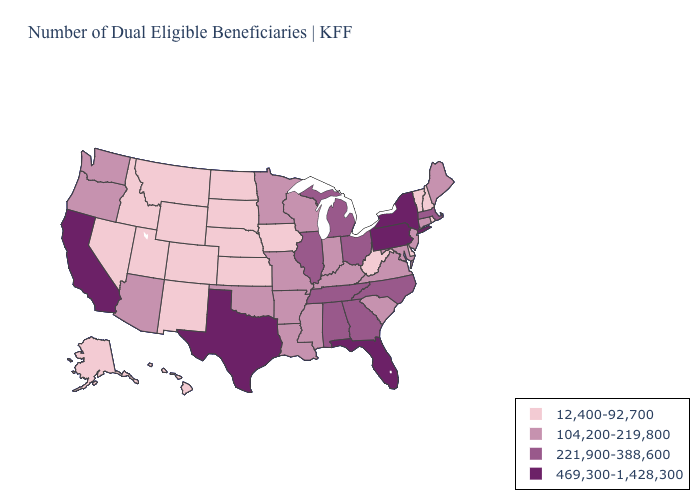Does Delaware have the lowest value in the South?
Concise answer only. Yes. Does the first symbol in the legend represent the smallest category?
Give a very brief answer. Yes. What is the lowest value in the South?
Quick response, please. 12,400-92,700. Does Pennsylvania have the highest value in the Northeast?
Give a very brief answer. Yes. Among the states that border Alabama , which have the lowest value?
Short answer required. Mississippi. Name the states that have a value in the range 104,200-219,800?
Be succinct. Arizona, Arkansas, Connecticut, Indiana, Kentucky, Louisiana, Maine, Maryland, Minnesota, Mississippi, Missouri, New Jersey, Oklahoma, Oregon, South Carolina, Virginia, Washington, Wisconsin. Does Rhode Island have the same value as Wisconsin?
Quick response, please. No. What is the value of Hawaii?
Short answer required. 12,400-92,700. Does Pennsylvania have the highest value in the Northeast?
Answer briefly. Yes. Which states have the lowest value in the USA?
Answer briefly. Alaska, Colorado, Delaware, Hawaii, Idaho, Iowa, Kansas, Montana, Nebraska, Nevada, New Hampshire, New Mexico, North Dakota, Rhode Island, South Dakota, Utah, Vermont, West Virginia, Wyoming. What is the highest value in states that border South Carolina?
Short answer required. 221,900-388,600. What is the value of New Mexico?
Answer briefly. 12,400-92,700. Name the states that have a value in the range 469,300-1,428,300?
Answer briefly. California, Florida, New York, Pennsylvania, Texas. Among the states that border New Hampshire , which have the lowest value?
Give a very brief answer. Vermont. Name the states that have a value in the range 469,300-1,428,300?
Be succinct. California, Florida, New York, Pennsylvania, Texas. 